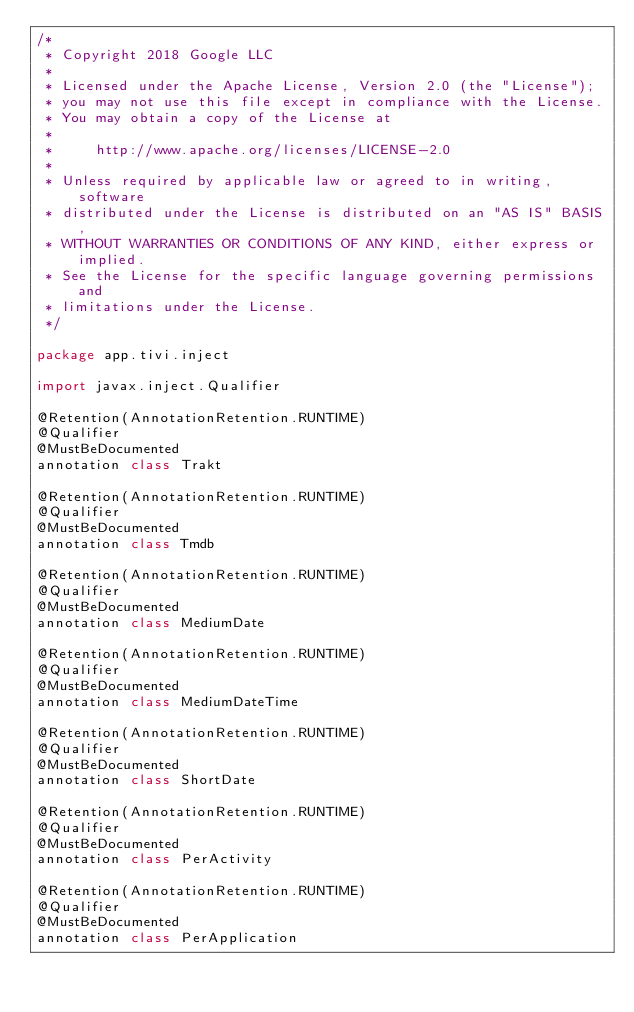Convert code to text. <code><loc_0><loc_0><loc_500><loc_500><_Kotlin_>/*
 * Copyright 2018 Google LLC
 *
 * Licensed under the Apache License, Version 2.0 (the "License");
 * you may not use this file except in compliance with the License.
 * You may obtain a copy of the License at
 *
 *     http://www.apache.org/licenses/LICENSE-2.0
 *
 * Unless required by applicable law or agreed to in writing, software
 * distributed under the License is distributed on an "AS IS" BASIS,
 * WITHOUT WARRANTIES OR CONDITIONS OF ANY KIND, either express or implied.
 * See the License for the specific language governing permissions and
 * limitations under the License.
 */

package app.tivi.inject

import javax.inject.Qualifier

@Retention(AnnotationRetention.RUNTIME)
@Qualifier
@MustBeDocumented
annotation class Trakt

@Retention(AnnotationRetention.RUNTIME)
@Qualifier
@MustBeDocumented
annotation class Tmdb

@Retention(AnnotationRetention.RUNTIME)
@Qualifier
@MustBeDocumented
annotation class MediumDate

@Retention(AnnotationRetention.RUNTIME)
@Qualifier
@MustBeDocumented
annotation class MediumDateTime

@Retention(AnnotationRetention.RUNTIME)
@Qualifier
@MustBeDocumented
annotation class ShortDate

@Retention(AnnotationRetention.RUNTIME)
@Qualifier
@MustBeDocumented
annotation class PerActivity

@Retention(AnnotationRetention.RUNTIME)
@Qualifier
@MustBeDocumented
annotation class PerApplication</code> 